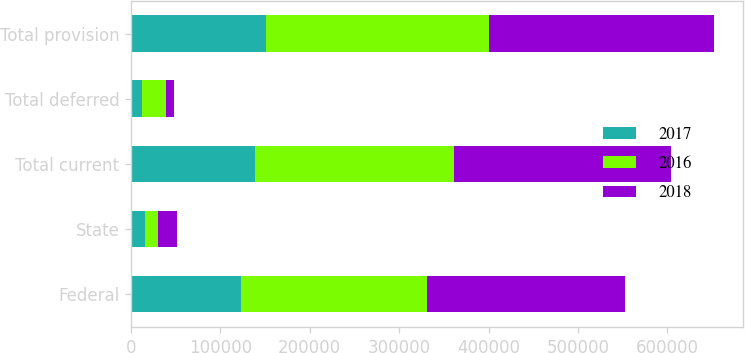<chart> <loc_0><loc_0><loc_500><loc_500><stacked_bar_chart><ecel><fcel>Federal<fcel>State<fcel>Total current<fcel>Total deferred<fcel>Total provision<nl><fcel>2017<fcel>123388<fcel>15597<fcel>138985<fcel>12043<fcel>151028<nl><fcel>2016<fcel>207986<fcel>14516<fcel>222502<fcel>27422<fcel>249924<nl><fcel>2018<fcel>221207<fcel>20858<fcel>242065<fcel>9085<fcel>251150<nl></chart> 